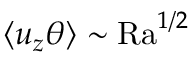Convert formula to latex. <formula><loc_0><loc_0><loc_500><loc_500>\left \langle u _ { z } \theta \right \rangle \sim R a ^ { 1 / 2 }</formula> 